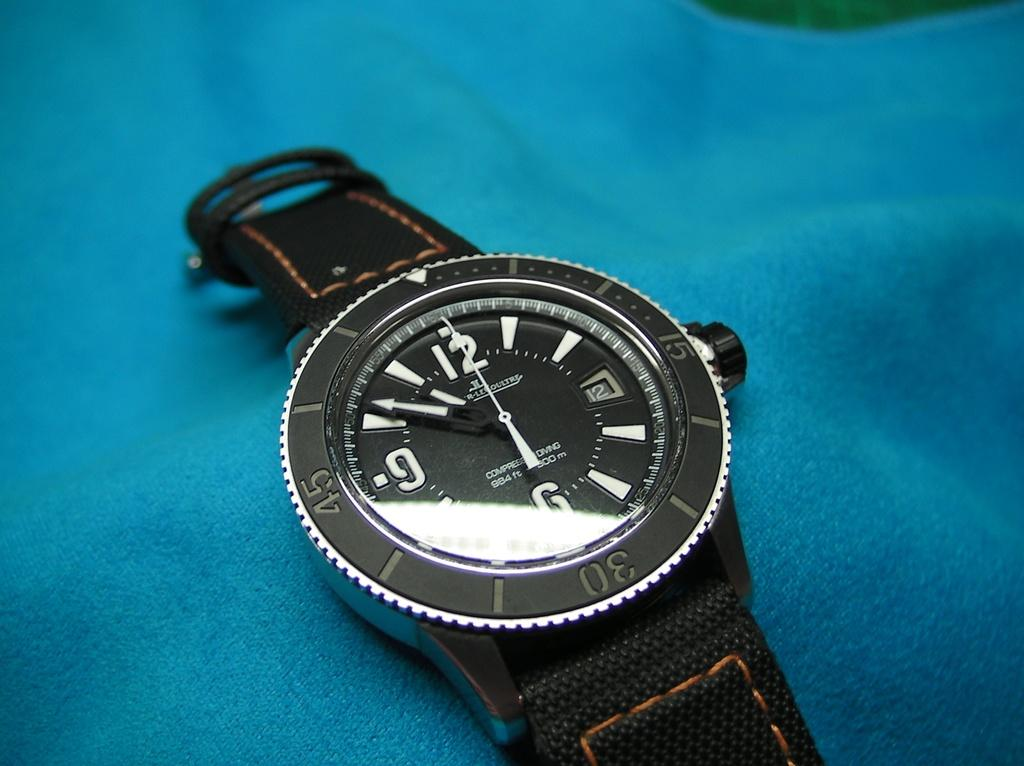<image>
Render a clear and concise summary of the photo. A black watch shows the time as 10:51. 